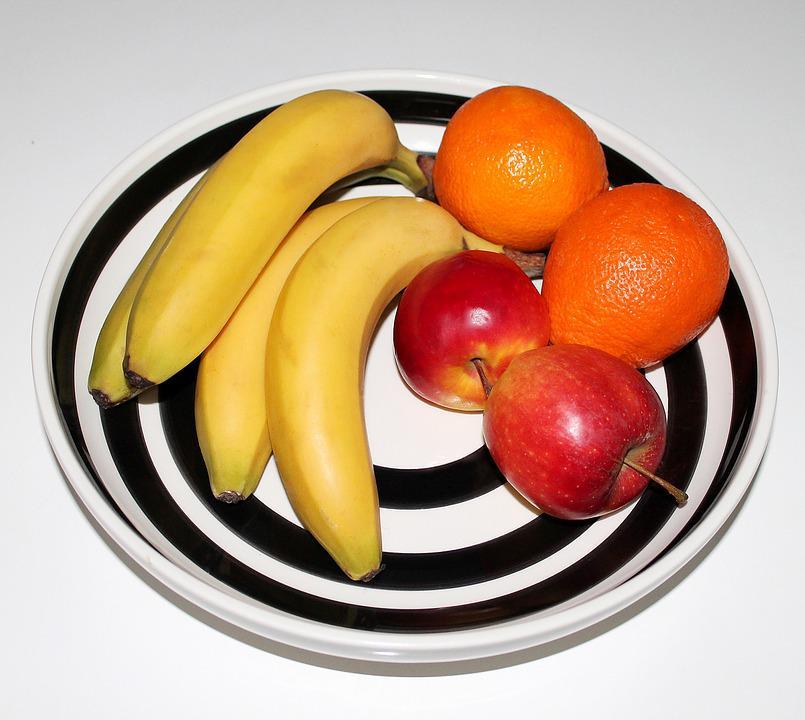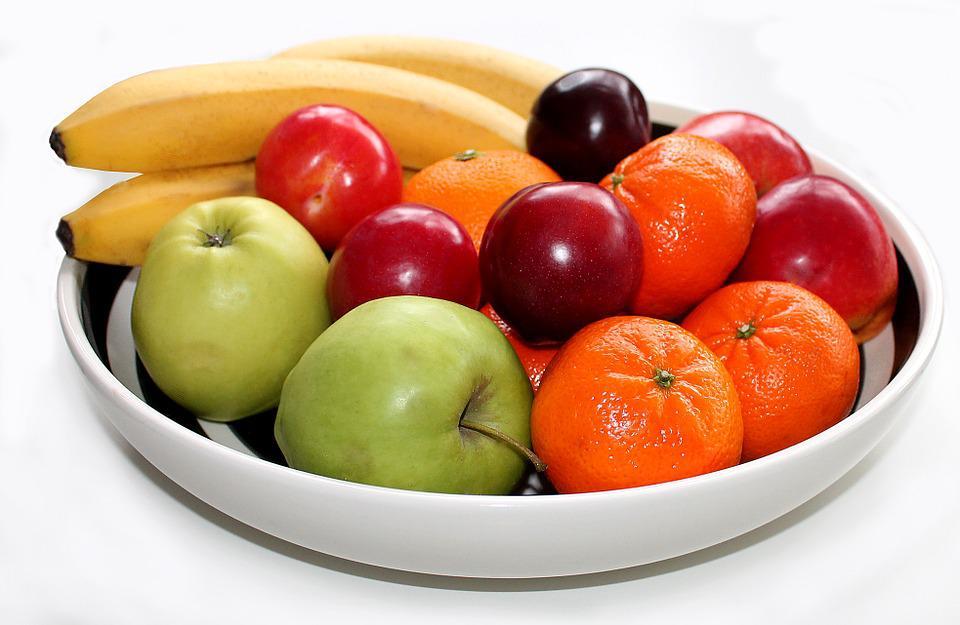The first image is the image on the left, the second image is the image on the right. Given the left and right images, does the statement "There are entirely green apples among the fruit in the right image." hold true? Answer yes or no. Yes. The first image is the image on the left, the second image is the image on the right. For the images shown, is this caption "An image shows fruit that is not in a container and includes at least one yellow banana and yellow-green pear." true? Answer yes or no. No. 